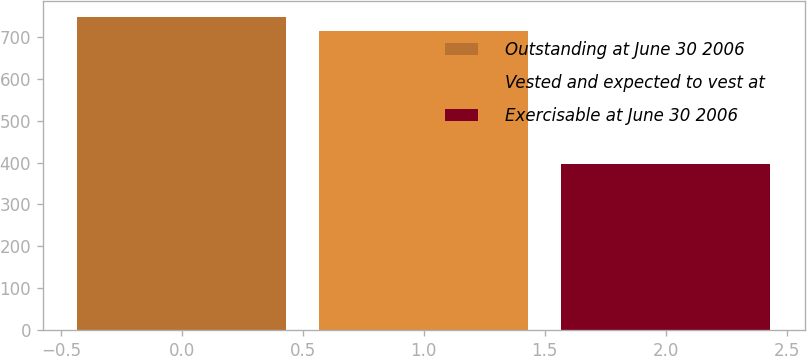<chart> <loc_0><loc_0><loc_500><loc_500><bar_chart><fcel>Outstanding at June 30 2006<fcel>Vested and expected to vest at<fcel>Exercisable at June 30 2006<nl><fcel>747.8<fcel>714<fcel>397<nl></chart> 